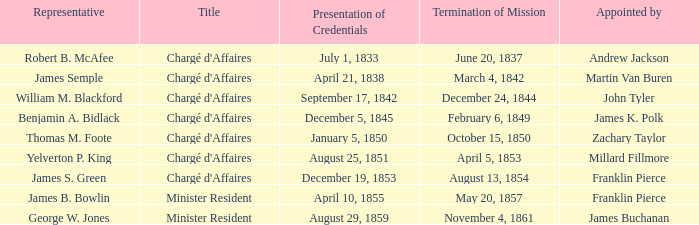What is the title of the mission that ended on november 4, 1861? Minister Resident. 